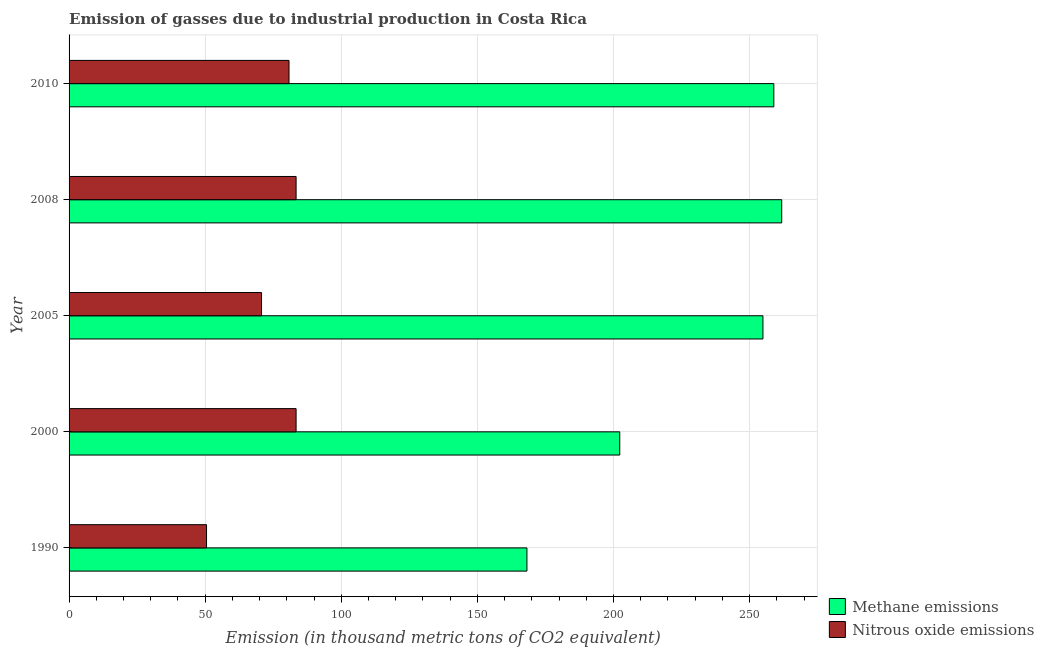How many different coloured bars are there?
Offer a very short reply. 2. How many bars are there on the 3rd tick from the top?
Your answer should be compact. 2. In how many cases, is the number of bars for a given year not equal to the number of legend labels?
Your answer should be compact. 0. What is the amount of nitrous oxide emissions in 2008?
Make the answer very short. 83.4. Across all years, what is the maximum amount of nitrous oxide emissions?
Your answer should be very brief. 83.4. Across all years, what is the minimum amount of nitrous oxide emissions?
Your answer should be very brief. 50.5. In which year was the amount of nitrous oxide emissions maximum?
Make the answer very short. 2000. What is the total amount of methane emissions in the graph?
Your answer should be compact. 1146.1. What is the difference between the amount of methane emissions in 2000 and that in 2005?
Keep it short and to the point. -52.6. What is the difference between the amount of nitrous oxide emissions in 2008 and the amount of methane emissions in 1990?
Keep it short and to the point. -84.8. What is the average amount of nitrous oxide emissions per year?
Give a very brief answer. 73.76. In the year 2000, what is the difference between the amount of methane emissions and amount of nitrous oxide emissions?
Your response must be concise. 118.9. What is the ratio of the amount of methane emissions in 2000 to that in 2010?
Offer a terse response. 0.78. What is the difference between the highest and the lowest amount of methane emissions?
Offer a terse response. 93.6. What does the 2nd bar from the top in 2010 represents?
Your answer should be compact. Methane emissions. What does the 1st bar from the bottom in 1990 represents?
Provide a short and direct response. Methane emissions. How many bars are there?
Ensure brevity in your answer.  10. Does the graph contain any zero values?
Provide a succinct answer. No. Does the graph contain grids?
Offer a terse response. Yes. Where does the legend appear in the graph?
Provide a short and direct response. Bottom right. What is the title of the graph?
Offer a very short reply. Emission of gasses due to industrial production in Costa Rica. What is the label or title of the X-axis?
Keep it short and to the point. Emission (in thousand metric tons of CO2 equivalent). What is the Emission (in thousand metric tons of CO2 equivalent) in Methane emissions in 1990?
Your answer should be very brief. 168.2. What is the Emission (in thousand metric tons of CO2 equivalent) in Nitrous oxide emissions in 1990?
Your answer should be compact. 50.5. What is the Emission (in thousand metric tons of CO2 equivalent) of Methane emissions in 2000?
Provide a short and direct response. 202.3. What is the Emission (in thousand metric tons of CO2 equivalent) of Nitrous oxide emissions in 2000?
Keep it short and to the point. 83.4. What is the Emission (in thousand metric tons of CO2 equivalent) of Methane emissions in 2005?
Your answer should be compact. 254.9. What is the Emission (in thousand metric tons of CO2 equivalent) in Nitrous oxide emissions in 2005?
Provide a succinct answer. 70.7. What is the Emission (in thousand metric tons of CO2 equivalent) in Methane emissions in 2008?
Provide a succinct answer. 261.8. What is the Emission (in thousand metric tons of CO2 equivalent) of Nitrous oxide emissions in 2008?
Your answer should be compact. 83.4. What is the Emission (in thousand metric tons of CO2 equivalent) in Methane emissions in 2010?
Ensure brevity in your answer.  258.9. What is the Emission (in thousand metric tons of CO2 equivalent) in Nitrous oxide emissions in 2010?
Provide a short and direct response. 80.8. Across all years, what is the maximum Emission (in thousand metric tons of CO2 equivalent) of Methane emissions?
Offer a terse response. 261.8. Across all years, what is the maximum Emission (in thousand metric tons of CO2 equivalent) of Nitrous oxide emissions?
Offer a terse response. 83.4. Across all years, what is the minimum Emission (in thousand metric tons of CO2 equivalent) in Methane emissions?
Offer a very short reply. 168.2. Across all years, what is the minimum Emission (in thousand metric tons of CO2 equivalent) of Nitrous oxide emissions?
Keep it short and to the point. 50.5. What is the total Emission (in thousand metric tons of CO2 equivalent) in Methane emissions in the graph?
Give a very brief answer. 1146.1. What is the total Emission (in thousand metric tons of CO2 equivalent) in Nitrous oxide emissions in the graph?
Provide a succinct answer. 368.8. What is the difference between the Emission (in thousand metric tons of CO2 equivalent) of Methane emissions in 1990 and that in 2000?
Give a very brief answer. -34.1. What is the difference between the Emission (in thousand metric tons of CO2 equivalent) of Nitrous oxide emissions in 1990 and that in 2000?
Your answer should be very brief. -32.9. What is the difference between the Emission (in thousand metric tons of CO2 equivalent) in Methane emissions in 1990 and that in 2005?
Your answer should be very brief. -86.7. What is the difference between the Emission (in thousand metric tons of CO2 equivalent) of Nitrous oxide emissions in 1990 and that in 2005?
Provide a short and direct response. -20.2. What is the difference between the Emission (in thousand metric tons of CO2 equivalent) of Methane emissions in 1990 and that in 2008?
Make the answer very short. -93.6. What is the difference between the Emission (in thousand metric tons of CO2 equivalent) in Nitrous oxide emissions in 1990 and that in 2008?
Provide a short and direct response. -32.9. What is the difference between the Emission (in thousand metric tons of CO2 equivalent) in Methane emissions in 1990 and that in 2010?
Keep it short and to the point. -90.7. What is the difference between the Emission (in thousand metric tons of CO2 equivalent) in Nitrous oxide emissions in 1990 and that in 2010?
Provide a succinct answer. -30.3. What is the difference between the Emission (in thousand metric tons of CO2 equivalent) in Methane emissions in 2000 and that in 2005?
Keep it short and to the point. -52.6. What is the difference between the Emission (in thousand metric tons of CO2 equivalent) in Methane emissions in 2000 and that in 2008?
Make the answer very short. -59.5. What is the difference between the Emission (in thousand metric tons of CO2 equivalent) of Nitrous oxide emissions in 2000 and that in 2008?
Provide a short and direct response. 0. What is the difference between the Emission (in thousand metric tons of CO2 equivalent) of Methane emissions in 2000 and that in 2010?
Ensure brevity in your answer.  -56.6. What is the difference between the Emission (in thousand metric tons of CO2 equivalent) of Methane emissions in 2005 and that in 2008?
Offer a terse response. -6.9. What is the difference between the Emission (in thousand metric tons of CO2 equivalent) of Nitrous oxide emissions in 2005 and that in 2008?
Give a very brief answer. -12.7. What is the difference between the Emission (in thousand metric tons of CO2 equivalent) in Nitrous oxide emissions in 2005 and that in 2010?
Offer a terse response. -10.1. What is the difference between the Emission (in thousand metric tons of CO2 equivalent) of Methane emissions in 2008 and that in 2010?
Your response must be concise. 2.9. What is the difference between the Emission (in thousand metric tons of CO2 equivalent) of Nitrous oxide emissions in 2008 and that in 2010?
Your answer should be very brief. 2.6. What is the difference between the Emission (in thousand metric tons of CO2 equivalent) in Methane emissions in 1990 and the Emission (in thousand metric tons of CO2 equivalent) in Nitrous oxide emissions in 2000?
Provide a succinct answer. 84.8. What is the difference between the Emission (in thousand metric tons of CO2 equivalent) in Methane emissions in 1990 and the Emission (in thousand metric tons of CO2 equivalent) in Nitrous oxide emissions in 2005?
Keep it short and to the point. 97.5. What is the difference between the Emission (in thousand metric tons of CO2 equivalent) of Methane emissions in 1990 and the Emission (in thousand metric tons of CO2 equivalent) of Nitrous oxide emissions in 2008?
Make the answer very short. 84.8. What is the difference between the Emission (in thousand metric tons of CO2 equivalent) in Methane emissions in 1990 and the Emission (in thousand metric tons of CO2 equivalent) in Nitrous oxide emissions in 2010?
Offer a terse response. 87.4. What is the difference between the Emission (in thousand metric tons of CO2 equivalent) in Methane emissions in 2000 and the Emission (in thousand metric tons of CO2 equivalent) in Nitrous oxide emissions in 2005?
Your answer should be very brief. 131.6. What is the difference between the Emission (in thousand metric tons of CO2 equivalent) in Methane emissions in 2000 and the Emission (in thousand metric tons of CO2 equivalent) in Nitrous oxide emissions in 2008?
Your answer should be very brief. 118.9. What is the difference between the Emission (in thousand metric tons of CO2 equivalent) of Methane emissions in 2000 and the Emission (in thousand metric tons of CO2 equivalent) of Nitrous oxide emissions in 2010?
Your answer should be very brief. 121.5. What is the difference between the Emission (in thousand metric tons of CO2 equivalent) in Methane emissions in 2005 and the Emission (in thousand metric tons of CO2 equivalent) in Nitrous oxide emissions in 2008?
Your answer should be very brief. 171.5. What is the difference between the Emission (in thousand metric tons of CO2 equivalent) in Methane emissions in 2005 and the Emission (in thousand metric tons of CO2 equivalent) in Nitrous oxide emissions in 2010?
Offer a very short reply. 174.1. What is the difference between the Emission (in thousand metric tons of CO2 equivalent) in Methane emissions in 2008 and the Emission (in thousand metric tons of CO2 equivalent) in Nitrous oxide emissions in 2010?
Ensure brevity in your answer.  181. What is the average Emission (in thousand metric tons of CO2 equivalent) in Methane emissions per year?
Keep it short and to the point. 229.22. What is the average Emission (in thousand metric tons of CO2 equivalent) in Nitrous oxide emissions per year?
Your response must be concise. 73.76. In the year 1990, what is the difference between the Emission (in thousand metric tons of CO2 equivalent) in Methane emissions and Emission (in thousand metric tons of CO2 equivalent) in Nitrous oxide emissions?
Your response must be concise. 117.7. In the year 2000, what is the difference between the Emission (in thousand metric tons of CO2 equivalent) in Methane emissions and Emission (in thousand metric tons of CO2 equivalent) in Nitrous oxide emissions?
Your answer should be compact. 118.9. In the year 2005, what is the difference between the Emission (in thousand metric tons of CO2 equivalent) of Methane emissions and Emission (in thousand metric tons of CO2 equivalent) of Nitrous oxide emissions?
Ensure brevity in your answer.  184.2. In the year 2008, what is the difference between the Emission (in thousand metric tons of CO2 equivalent) in Methane emissions and Emission (in thousand metric tons of CO2 equivalent) in Nitrous oxide emissions?
Offer a terse response. 178.4. In the year 2010, what is the difference between the Emission (in thousand metric tons of CO2 equivalent) in Methane emissions and Emission (in thousand metric tons of CO2 equivalent) in Nitrous oxide emissions?
Keep it short and to the point. 178.1. What is the ratio of the Emission (in thousand metric tons of CO2 equivalent) of Methane emissions in 1990 to that in 2000?
Provide a succinct answer. 0.83. What is the ratio of the Emission (in thousand metric tons of CO2 equivalent) of Nitrous oxide emissions in 1990 to that in 2000?
Provide a short and direct response. 0.61. What is the ratio of the Emission (in thousand metric tons of CO2 equivalent) in Methane emissions in 1990 to that in 2005?
Make the answer very short. 0.66. What is the ratio of the Emission (in thousand metric tons of CO2 equivalent) of Methane emissions in 1990 to that in 2008?
Give a very brief answer. 0.64. What is the ratio of the Emission (in thousand metric tons of CO2 equivalent) in Nitrous oxide emissions in 1990 to that in 2008?
Make the answer very short. 0.61. What is the ratio of the Emission (in thousand metric tons of CO2 equivalent) of Methane emissions in 1990 to that in 2010?
Offer a terse response. 0.65. What is the ratio of the Emission (in thousand metric tons of CO2 equivalent) of Methane emissions in 2000 to that in 2005?
Offer a very short reply. 0.79. What is the ratio of the Emission (in thousand metric tons of CO2 equivalent) of Nitrous oxide emissions in 2000 to that in 2005?
Provide a short and direct response. 1.18. What is the ratio of the Emission (in thousand metric tons of CO2 equivalent) in Methane emissions in 2000 to that in 2008?
Provide a succinct answer. 0.77. What is the ratio of the Emission (in thousand metric tons of CO2 equivalent) in Nitrous oxide emissions in 2000 to that in 2008?
Your answer should be very brief. 1. What is the ratio of the Emission (in thousand metric tons of CO2 equivalent) in Methane emissions in 2000 to that in 2010?
Your response must be concise. 0.78. What is the ratio of the Emission (in thousand metric tons of CO2 equivalent) in Nitrous oxide emissions in 2000 to that in 2010?
Make the answer very short. 1.03. What is the ratio of the Emission (in thousand metric tons of CO2 equivalent) of Methane emissions in 2005 to that in 2008?
Provide a succinct answer. 0.97. What is the ratio of the Emission (in thousand metric tons of CO2 equivalent) in Nitrous oxide emissions in 2005 to that in 2008?
Your response must be concise. 0.85. What is the ratio of the Emission (in thousand metric tons of CO2 equivalent) in Methane emissions in 2005 to that in 2010?
Offer a terse response. 0.98. What is the ratio of the Emission (in thousand metric tons of CO2 equivalent) of Nitrous oxide emissions in 2005 to that in 2010?
Give a very brief answer. 0.88. What is the ratio of the Emission (in thousand metric tons of CO2 equivalent) in Methane emissions in 2008 to that in 2010?
Keep it short and to the point. 1.01. What is the ratio of the Emission (in thousand metric tons of CO2 equivalent) of Nitrous oxide emissions in 2008 to that in 2010?
Keep it short and to the point. 1.03. What is the difference between the highest and the lowest Emission (in thousand metric tons of CO2 equivalent) in Methane emissions?
Offer a very short reply. 93.6. What is the difference between the highest and the lowest Emission (in thousand metric tons of CO2 equivalent) in Nitrous oxide emissions?
Your answer should be compact. 32.9. 